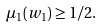<formula> <loc_0><loc_0><loc_500><loc_500>\mu _ { 1 } ( w _ { 1 } ) \geq 1 / 2 .</formula> 